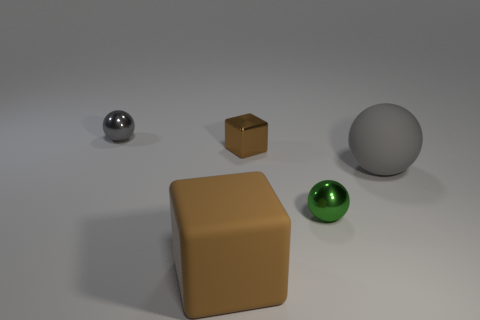Add 4 red matte spheres. How many objects exist? 9 Subtract all cubes. How many objects are left? 3 Add 3 brown metal things. How many brown metal things are left? 4 Add 5 brown matte things. How many brown matte things exist? 6 Subtract 1 green balls. How many objects are left? 4 Subtract all big brown rubber cubes. Subtract all tiny shiny spheres. How many objects are left? 2 